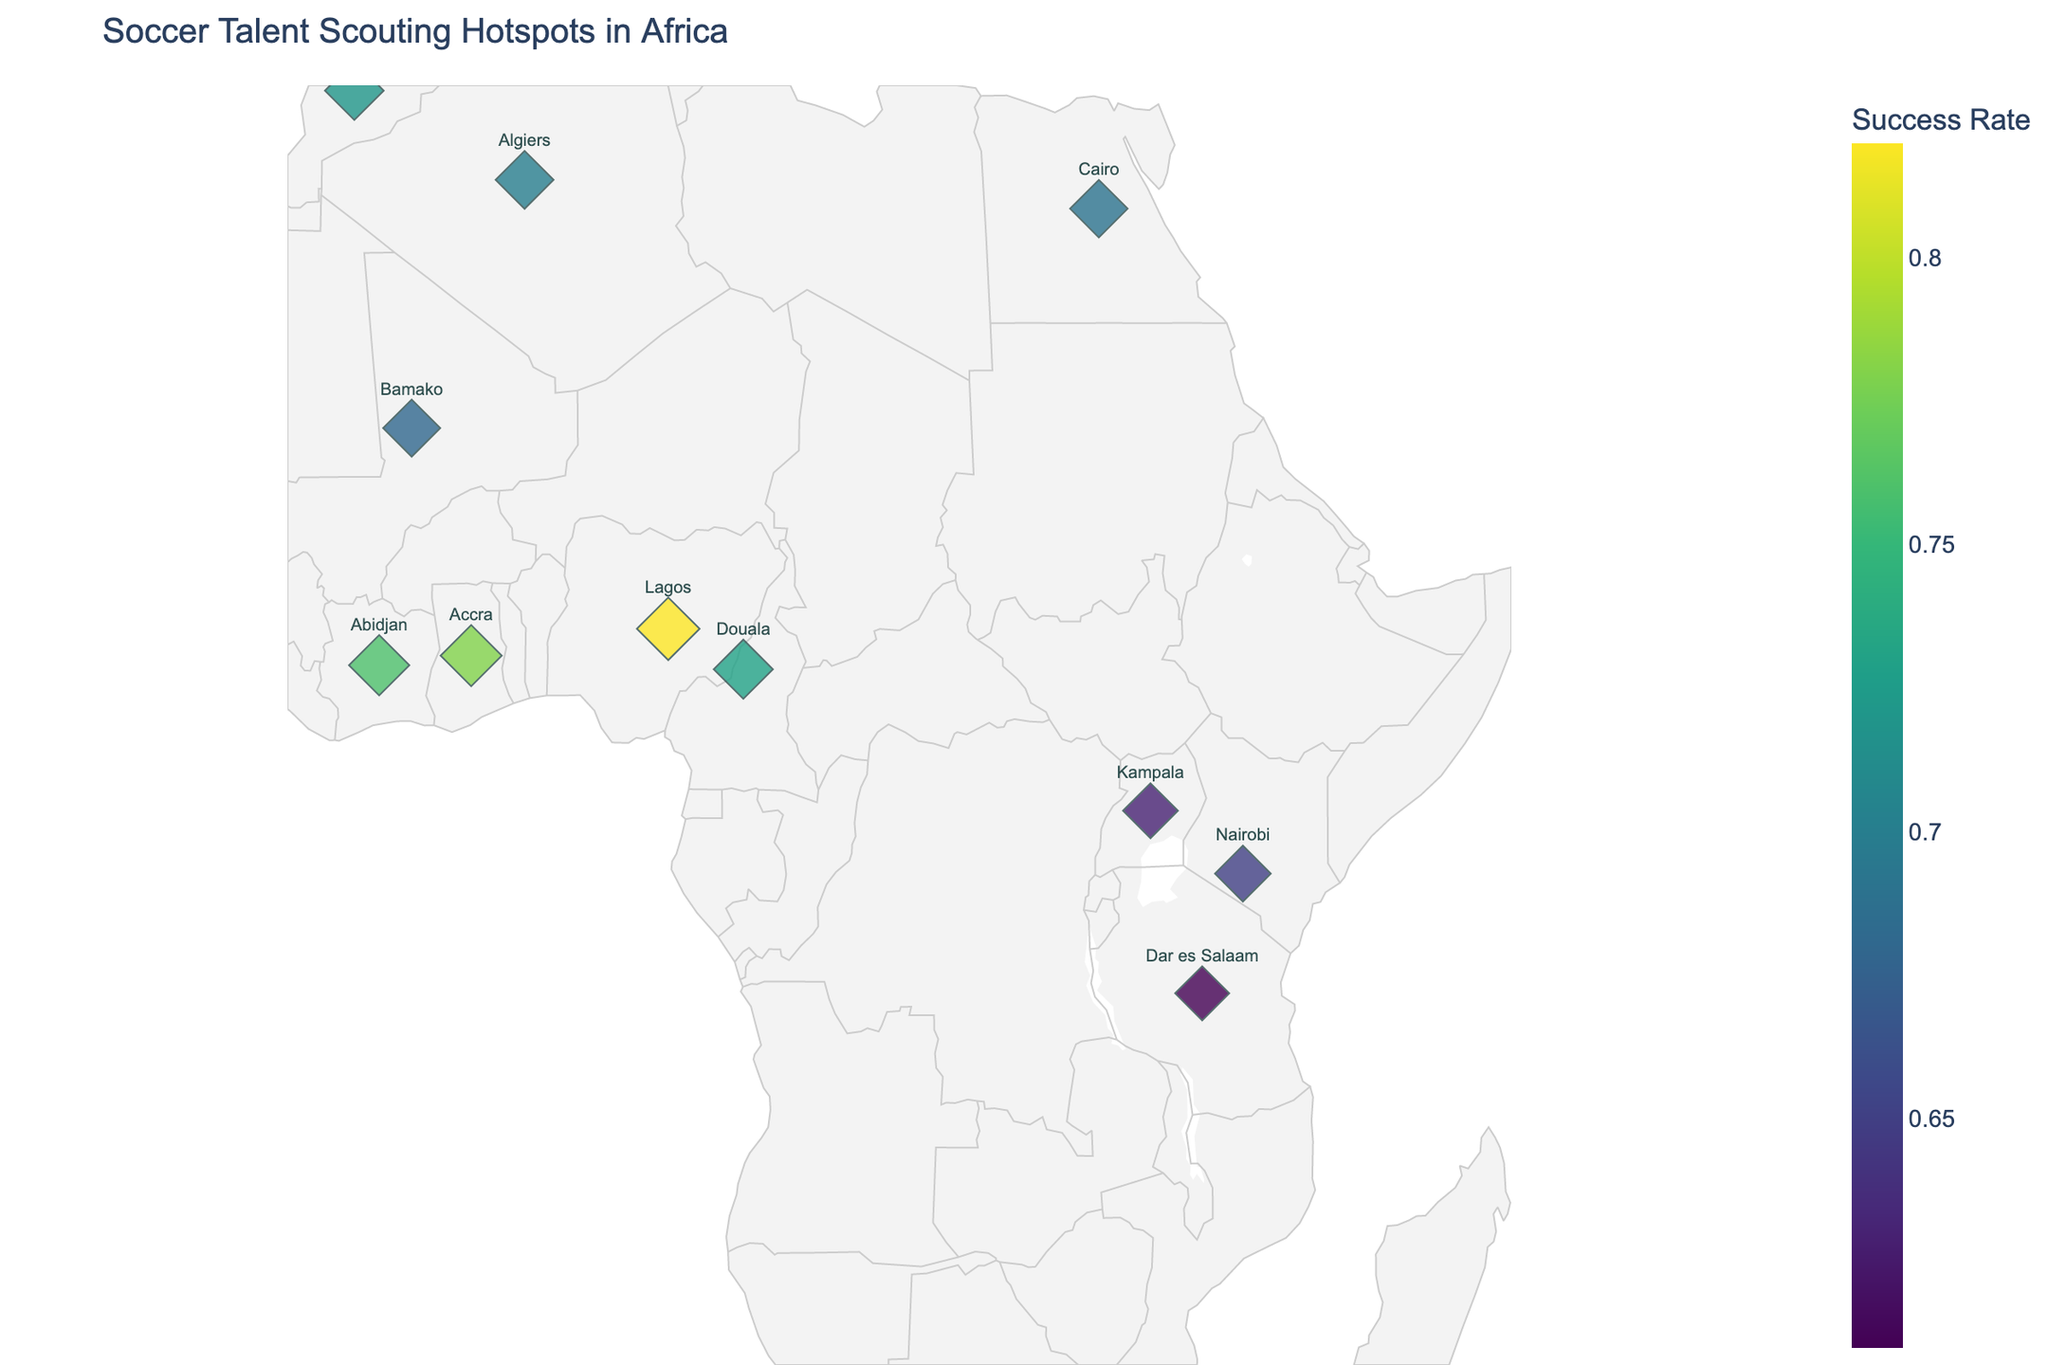What is the title of the figure? The title of the figure can be found at the top, indicating the purpose of the plot. It reads "Soccer Talent Scouting Hotspots in Africa".
Answer: Soccer Talent Scouting Hotspots in Africa Which hotspot has the highest success rate? By examining the color and size of the markers, Lagos in Nigeria stands out as having the highest success rate, indicated by the largest marker and darkest shade in the Viridis color scale.
Answer: Lagos Which country is represented near the coordinates (14.4974, -14.4524)? By matching the given coordinates with those in the plot, the corresponding country is identified. The data point at (14.4974, -14.4524) represents Dakar, Senegal.
Answer: Senegal Compare the success rates of Johannesburg and Abidjan. Which one is higher? By comparing the sizes and colors of the markers at the locations of Johannesburg and Abidjan, the success rates can be evaluated. Johannesburg has a success rate of 0.75, while Abidjan has a success rate of 0.76. Abidjan's success rate is higher.
Answer: Abidjan What's the average success rate of the hotspots in West Africa (Nigeria, Ghana, Senegal, Ivory Coast, and Mali)? Calculate the average success rate by summing the success rates of the West African hotspots and dividing by the number of hotspots. (0.82 + 0.78 + 0.71 + 0.76 + 0.68) / 5 = 3.75 / 5 = 0.75
Answer: 0.75 Identify the hotspot with the lowest success rate and its country. By locating the smallest and lightest-colored marker in the plot, the hotspot with the lowest success rate can be found. Dar es Salaam in Tanzania has the lowest success rate, indicated by a rate of 0.61.
Answer: Dar es Salaam, Tanzania Which three hotspots have success rates above 0.75 and in what countries are they located? Examine the plot for markers with success rates greater than 0.75, indicated by larger sizes and darker colors. The hotspots are Lagos (Nigeria), Accra (Ghana), and Abidjan (Ivory Coast).
Answer: Lagos, Accra, Abidjan How does the success rate of Cairo compare to Casablanca? Compare the sizes and colors of the markers in Cairo and Casablanca. Cairo has a success rate of 0.69, while Casablanca has a success rate of 0.72, so Casablanca has a higher success rate.
Answer: Casablanca What is the median success rate of all the hotspots? Arrange the success rates in ascending order and find the middle value. The rates are 0.61, 0.63, 0.65, 0.68, 0.69, 0.70, 0.71, 0.72, 0.73, 0.75, 0.76, 0.78, 0.82. The middle value is 0.70, which is the median.
Answer: 0.70 